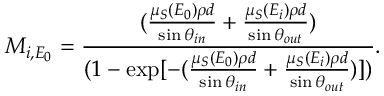<formula> <loc_0><loc_0><loc_500><loc_500>M _ { i , E _ { 0 } } = \frac { ( \frac { \mu _ { S } ( E _ { 0 } ) \rho d } { \sin \theta _ { i n } } + \frac { \mu _ { S } ( E _ { i } ) \rho d } { \sin \theta _ { o u t } } ) } { ( 1 - \exp [ - ( \frac { \mu _ { S } ( E _ { 0 } ) \rho d } { \sin \theta _ { i n } } + \frac { \mu _ { S } ( E _ { i } ) \rho d } { \sin \theta _ { o u t } } ) ] ) } .</formula> 